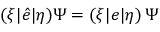Convert formula to latex. <formula><loc_0><loc_0><loc_500><loc_500>( \xi | \hat { e } | \eta ) \Psi = ( \xi | e | \eta ) \, \Psi</formula> 